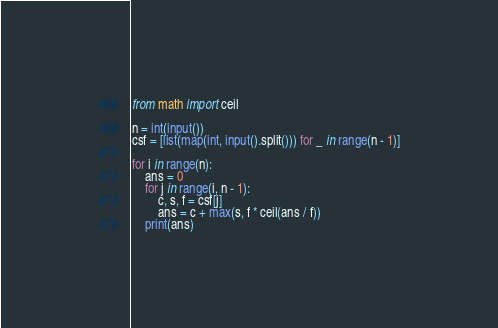<code> <loc_0><loc_0><loc_500><loc_500><_Python_>from math import ceil

n = int(input())
csf = [list(map(int, input().split())) for _ in range(n - 1)]

for i in range(n):
    ans = 0
    for j in range(i, n - 1):
        c, s, f = csf[j]
        ans = c + max(s, f * ceil(ans / f))
    print(ans)</code> 